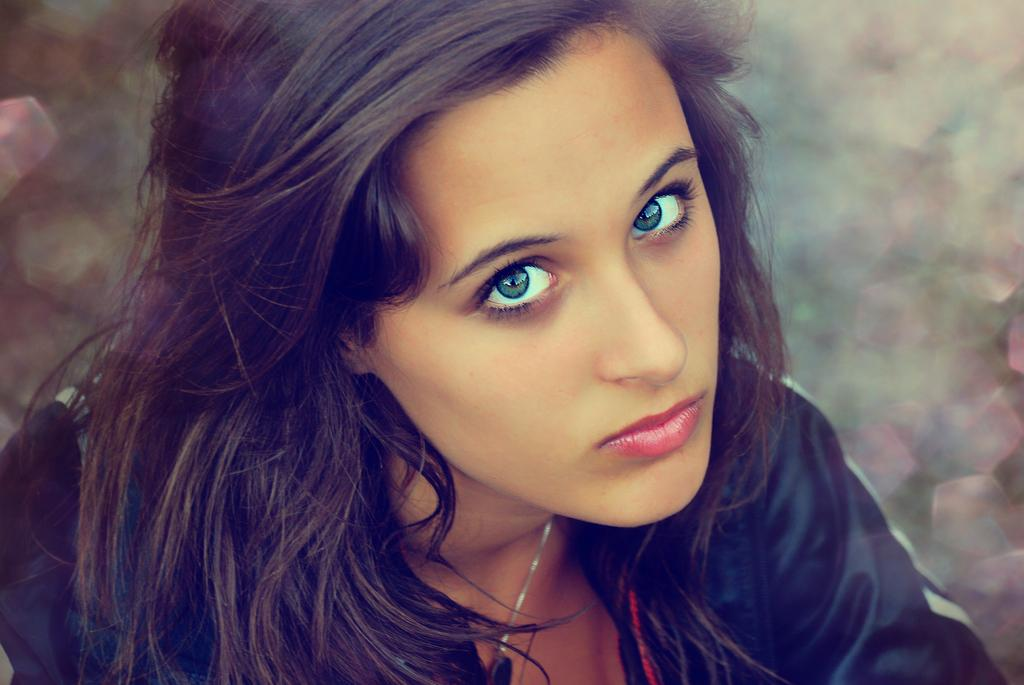Who is the main subject in the image? There is a woman in the image. Can you describe the background of the image? The background of the image is blurry. What degree does the woman hold in the image? There is no information about the woman's degree in the image. What event is the woman attending in the image? There is no indication of an event in the image. 